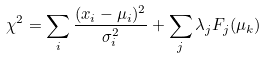<formula> <loc_0><loc_0><loc_500><loc_500>\chi ^ { 2 } = \sum _ { i } { \frac { ( x _ { i } - \mu _ { i } ) ^ { 2 } } { \sigma _ { i } ^ { 2 } } } + \sum _ { j } { \lambda _ { j } F _ { j } ( \mu _ { k } ) }</formula> 